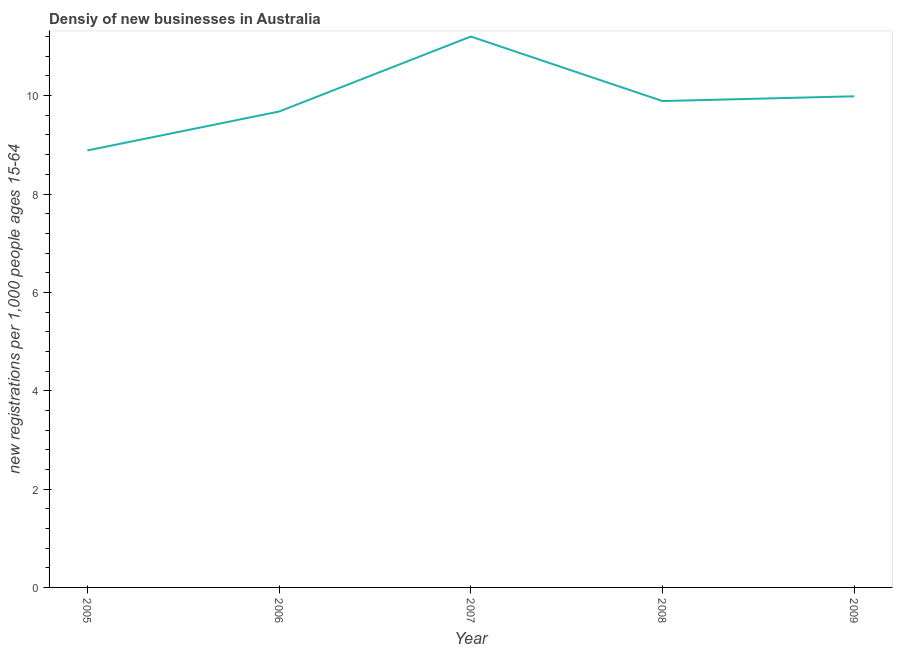What is the density of new business in 2006?
Your response must be concise. 9.68. Across all years, what is the maximum density of new business?
Offer a very short reply. 11.2. Across all years, what is the minimum density of new business?
Make the answer very short. 8.89. In which year was the density of new business maximum?
Give a very brief answer. 2007. What is the sum of the density of new business?
Your response must be concise. 49.64. What is the difference between the density of new business in 2005 and 2009?
Give a very brief answer. -1.1. What is the average density of new business per year?
Provide a succinct answer. 9.93. What is the median density of new business?
Make the answer very short. 9.89. Do a majority of the years between 2009 and 2006 (inclusive) have density of new business greater than 9.2 ?
Your response must be concise. Yes. What is the ratio of the density of new business in 2007 to that in 2008?
Provide a succinct answer. 1.13. What is the difference between the highest and the second highest density of new business?
Your answer should be compact. 1.22. Is the sum of the density of new business in 2005 and 2008 greater than the maximum density of new business across all years?
Ensure brevity in your answer.  Yes. What is the difference between the highest and the lowest density of new business?
Ensure brevity in your answer.  2.32. Does the density of new business monotonically increase over the years?
Keep it short and to the point. No. How many lines are there?
Make the answer very short. 1. Does the graph contain any zero values?
Make the answer very short. No. Does the graph contain grids?
Your answer should be compact. No. What is the title of the graph?
Provide a short and direct response. Densiy of new businesses in Australia. What is the label or title of the X-axis?
Provide a short and direct response. Year. What is the label or title of the Y-axis?
Ensure brevity in your answer.  New registrations per 1,0 people ages 15-64. What is the new registrations per 1,000 people ages 15-64 in 2005?
Give a very brief answer. 8.89. What is the new registrations per 1,000 people ages 15-64 of 2006?
Provide a succinct answer. 9.68. What is the new registrations per 1,000 people ages 15-64 in 2007?
Provide a short and direct response. 11.2. What is the new registrations per 1,000 people ages 15-64 in 2008?
Offer a terse response. 9.89. What is the new registrations per 1,000 people ages 15-64 in 2009?
Offer a terse response. 9.99. What is the difference between the new registrations per 1,000 people ages 15-64 in 2005 and 2006?
Your answer should be compact. -0.79. What is the difference between the new registrations per 1,000 people ages 15-64 in 2005 and 2007?
Provide a succinct answer. -2.32. What is the difference between the new registrations per 1,000 people ages 15-64 in 2005 and 2008?
Provide a short and direct response. -1. What is the difference between the new registrations per 1,000 people ages 15-64 in 2005 and 2009?
Make the answer very short. -1.1. What is the difference between the new registrations per 1,000 people ages 15-64 in 2006 and 2007?
Your answer should be very brief. -1.53. What is the difference between the new registrations per 1,000 people ages 15-64 in 2006 and 2008?
Offer a very short reply. -0.21. What is the difference between the new registrations per 1,000 people ages 15-64 in 2006 and 2009?
Provide a succinct answer. -0.31. What is the difference between the new registrations per 1,000 people ages 15-64 in 2007 and 2008?
Provide a short and direct response. 1.31. What is the difference between the new registrations per 1,000 people ages 15-64 in 2007 and 2009?
Provide a succinct answer. 1.22. What is the difference between the new registrations per 1,000 people ages 15-64 in 2008 and 2009?
Your response must be concise. -0.1. What is the ratio of the new registrations per 1,000 people ages 15-64 in 2005 to that in 2006?
Offer a very short reply. 0.92. What is the ratio of the new registrations per 1,000 people ages 15-64 in 2005 to that in 2007?
Offer a terse response. 0.79. What is the ratio of the new registrations per 1,000 people ages 15-64 in 2005 to that in 2008?
Give a very brief answer. 0.9. What is the ratio of the new registrations per 1,000 people ages 15-64 in 2005 to that in 2009?
Offer a very short reply. 0.89. What is the ratio of the new registrations per 1,000 people ages 15-64 in 2006 to that in 2007?
Offer a very short reply. 0.86. What is the ratio of the new registrations per 1,000 people ages 15-64 in 2006 to that in 2009?
Give a very brief answer. 0.97. What is the ratio of the new registrations per 1,000 people ages 15-64 in 2007 to that in 2008?
Your response must be concise. 1.13. What is the ratio of the new registrations per 1,000 people ages 15-64 in 2007 to that in 2009?
Provide a succinct answer. 1.12. What is the ratio of the new registrations per 1,000 people ages 15-64 in 2008 to that in 2009?
Ensure brevity in your answer.  0.99. 